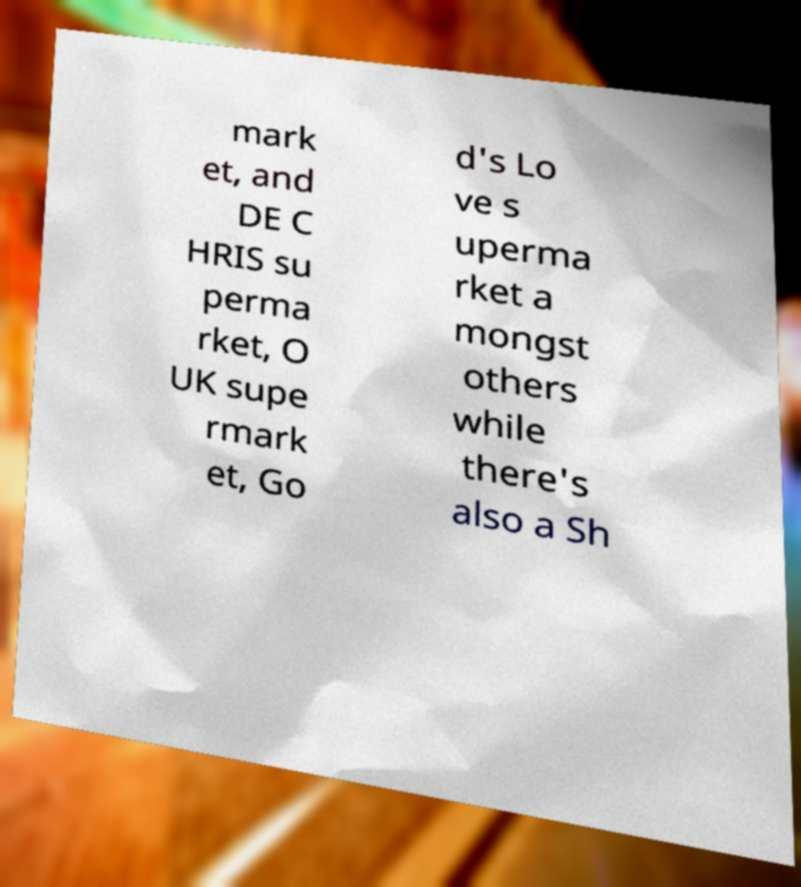Can you read and provide the text displayed in the image?This photo seems to have some interesting text. Can you extract and type it out for me? mark et, and DE C HRIS su perma rket, O UK supe rmark et, Go d's Lo ve s uperma rket a mongst others while there's also a Sh 